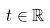<formula> <loc_0><loc_0><loc_500><loc_500>t \in \mathbb { R }</formula> 